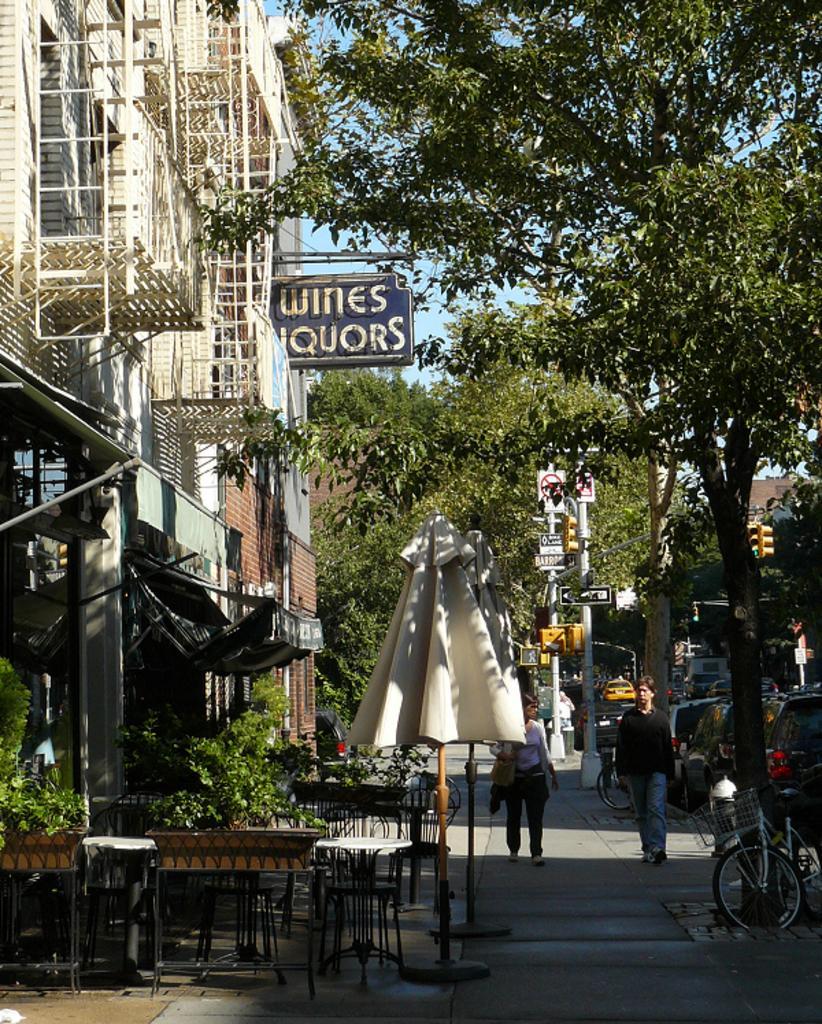Please provide a concise description of this image. In this image we can see the buildings, plants, trees, sign board poles, closed rents, bicycles and cars. We can also see the tables and chairs. We can see two persons walking on the path. 